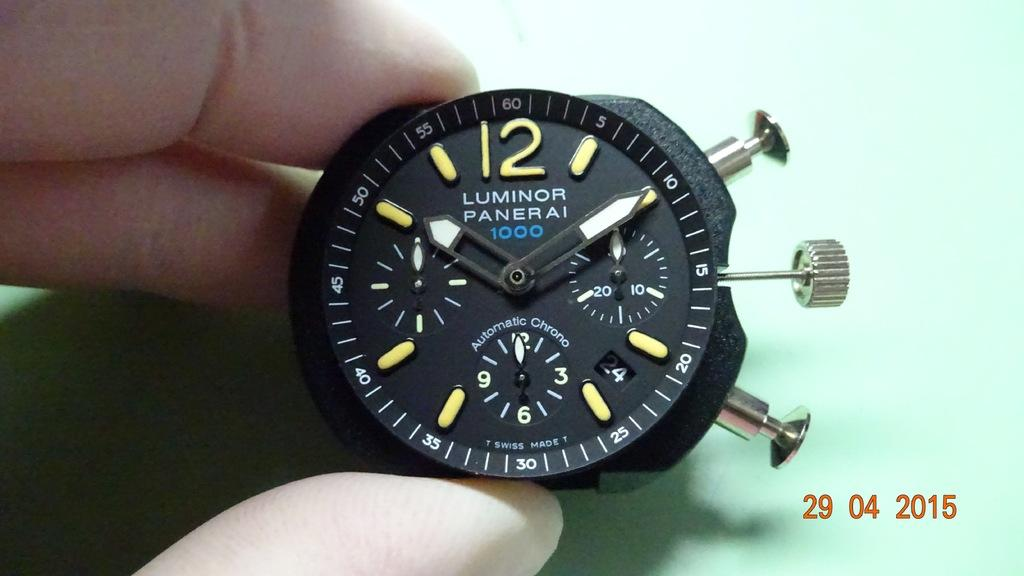<image>
Summarize the visual content of the image. A Luminor watch displays a black screen and bright green number symbols. 